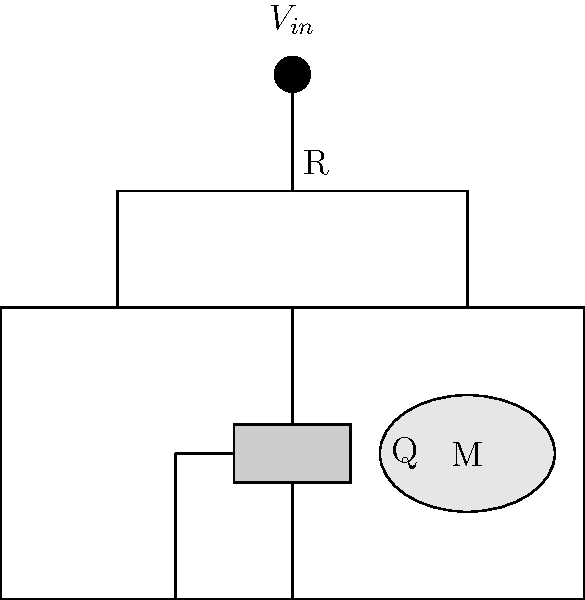In the given circuit diagram for a simple trolling motor speed control, what is the purpose of the resistor R connected between $V_{in}$ and the gate of the MOSFET Q? To understand the purpose of resistor R in this trolling motor speed control circuit, let's follow these steps:

1. Identify the components:
   - $V_{in}$ is the input voltage (likely from a battery or power source)
   - R is a resistor
   - Q is a MOSFET (Metal-Oxide-Semiconductor Field-Effect Transistor)
   - M is the trolling motor

2. Understand the MOSFET operation:
   - MOSFETs are voltage-controlled devices
   - The gate voltage controls the current flow between the source and drain

3. Analyze the resistor's role:
   - R is connected between $V_{in}$ and the MOSFET's gate
   - It forms a voltage divider with the MOSFET's internal gate-source capacitance

4. Determine the resistor's functions:
   a) Current limiting: It limits the current flowing into the gate during switching
   b) Gate protection: It protects the gate from voltage spikes
   c) Turn-off speed control: It affects how quickly the MOSFET turns off when $V_{in}$ is removed

5. Consider the implications for motor control:
   - The resistor helps create a soft start/stop effect for the motor
   - It can reduce electromagnetic interference (EMI) caused by rapid switching

In essence, resistor R serves as a crucial component for protecting the MOSFET and controlling the motor's behavior in this simple trolling motor speed control circuit.
Answer: To limit gate current, protect the MOSFET, and control turn-off speed 